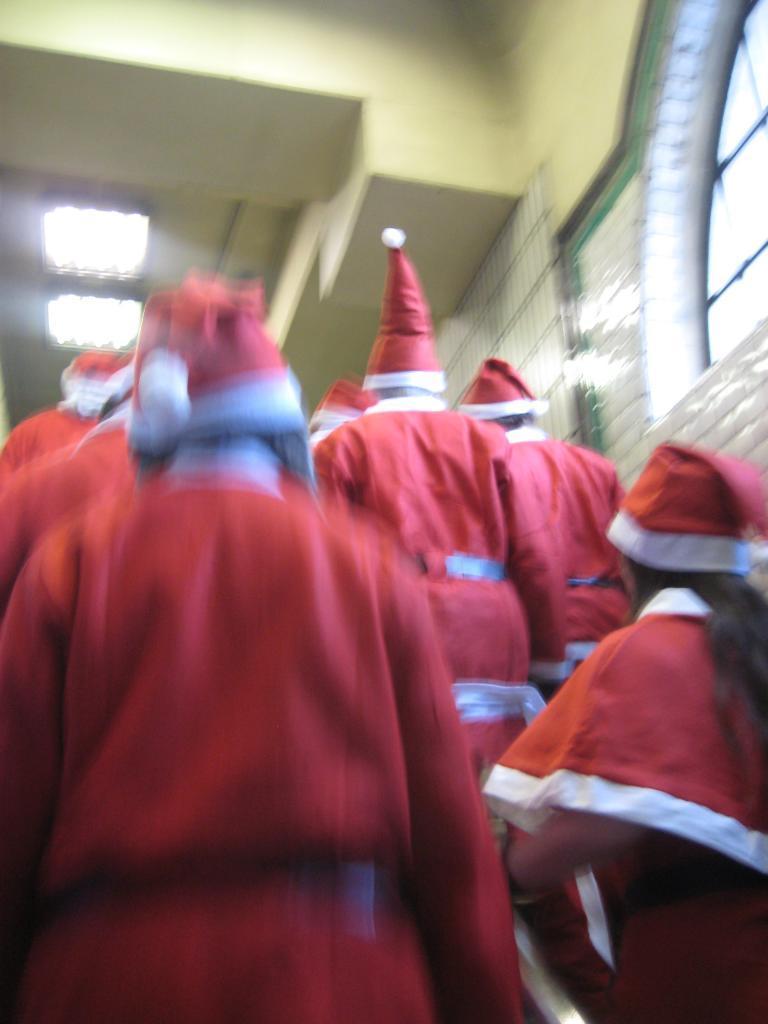Could you give a brief overview of what you see in this image? In this image there are few people in the middle who are wearing the santa claus dress and standing one beside the other in the line. On the right side top there is a glass window. At the top there are lights. 